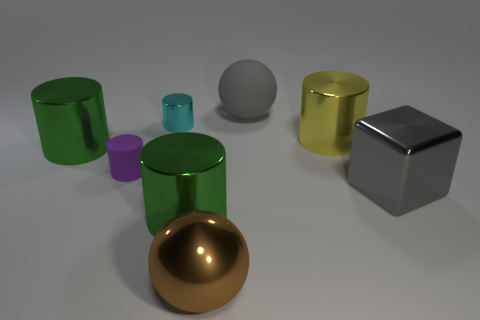Subtract 1 cylinders. How many cylinders are left? 4 Subtract all purple cylinders. How many cylinders are left? 4 Subtract all yellow shiny cylinders. How many cylinders are left? 4 Add 1 yellow metal things. How many objects exist? 9 Subtract all brown cylinders. Subtract all gray cubes. How many cylinders are left? 5 Subtract all cylinders. How many objects are left? 3 Subtract 1 cyan cylinders. How many objects are left? 7 Subtract all brown spheres. Subtract all tiny metallic objects. How many objects are left? 6 Add 8 tiny purple things. How many tiny purple things are left? 9 Add 2 small brown matte spheres. How many small brown matte spheres exist? 2 